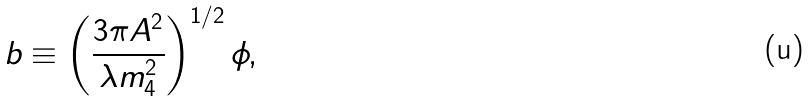Convert formula to latex. <formula><loc_0><loc_0><loc_500><loc_500>b \equiv \left ( \frac { 3 \pi A ^ { 2 } } { \lambda m ^ { 2 } _ { 4 } } \right ) ^ { 1 / 2 } \phi ,</formula> 